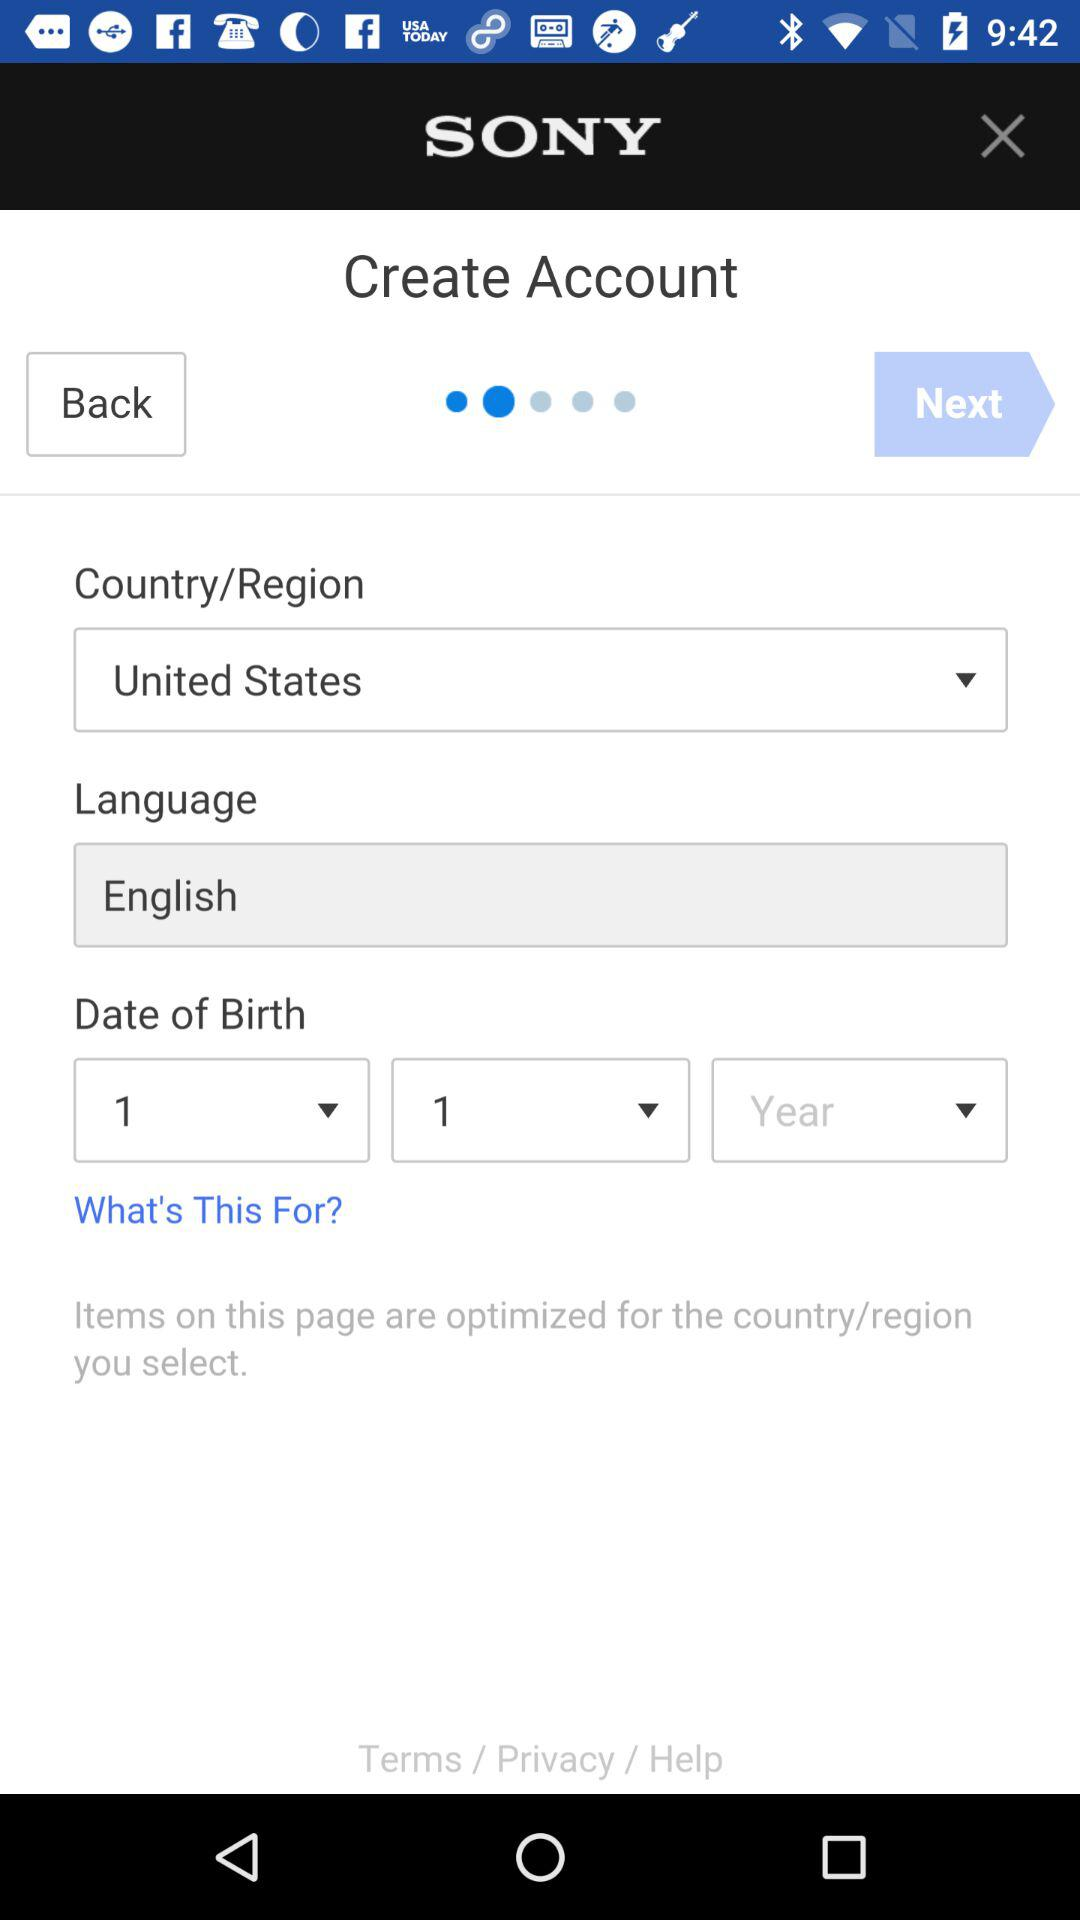Which language was selected? The selected language was "English". 